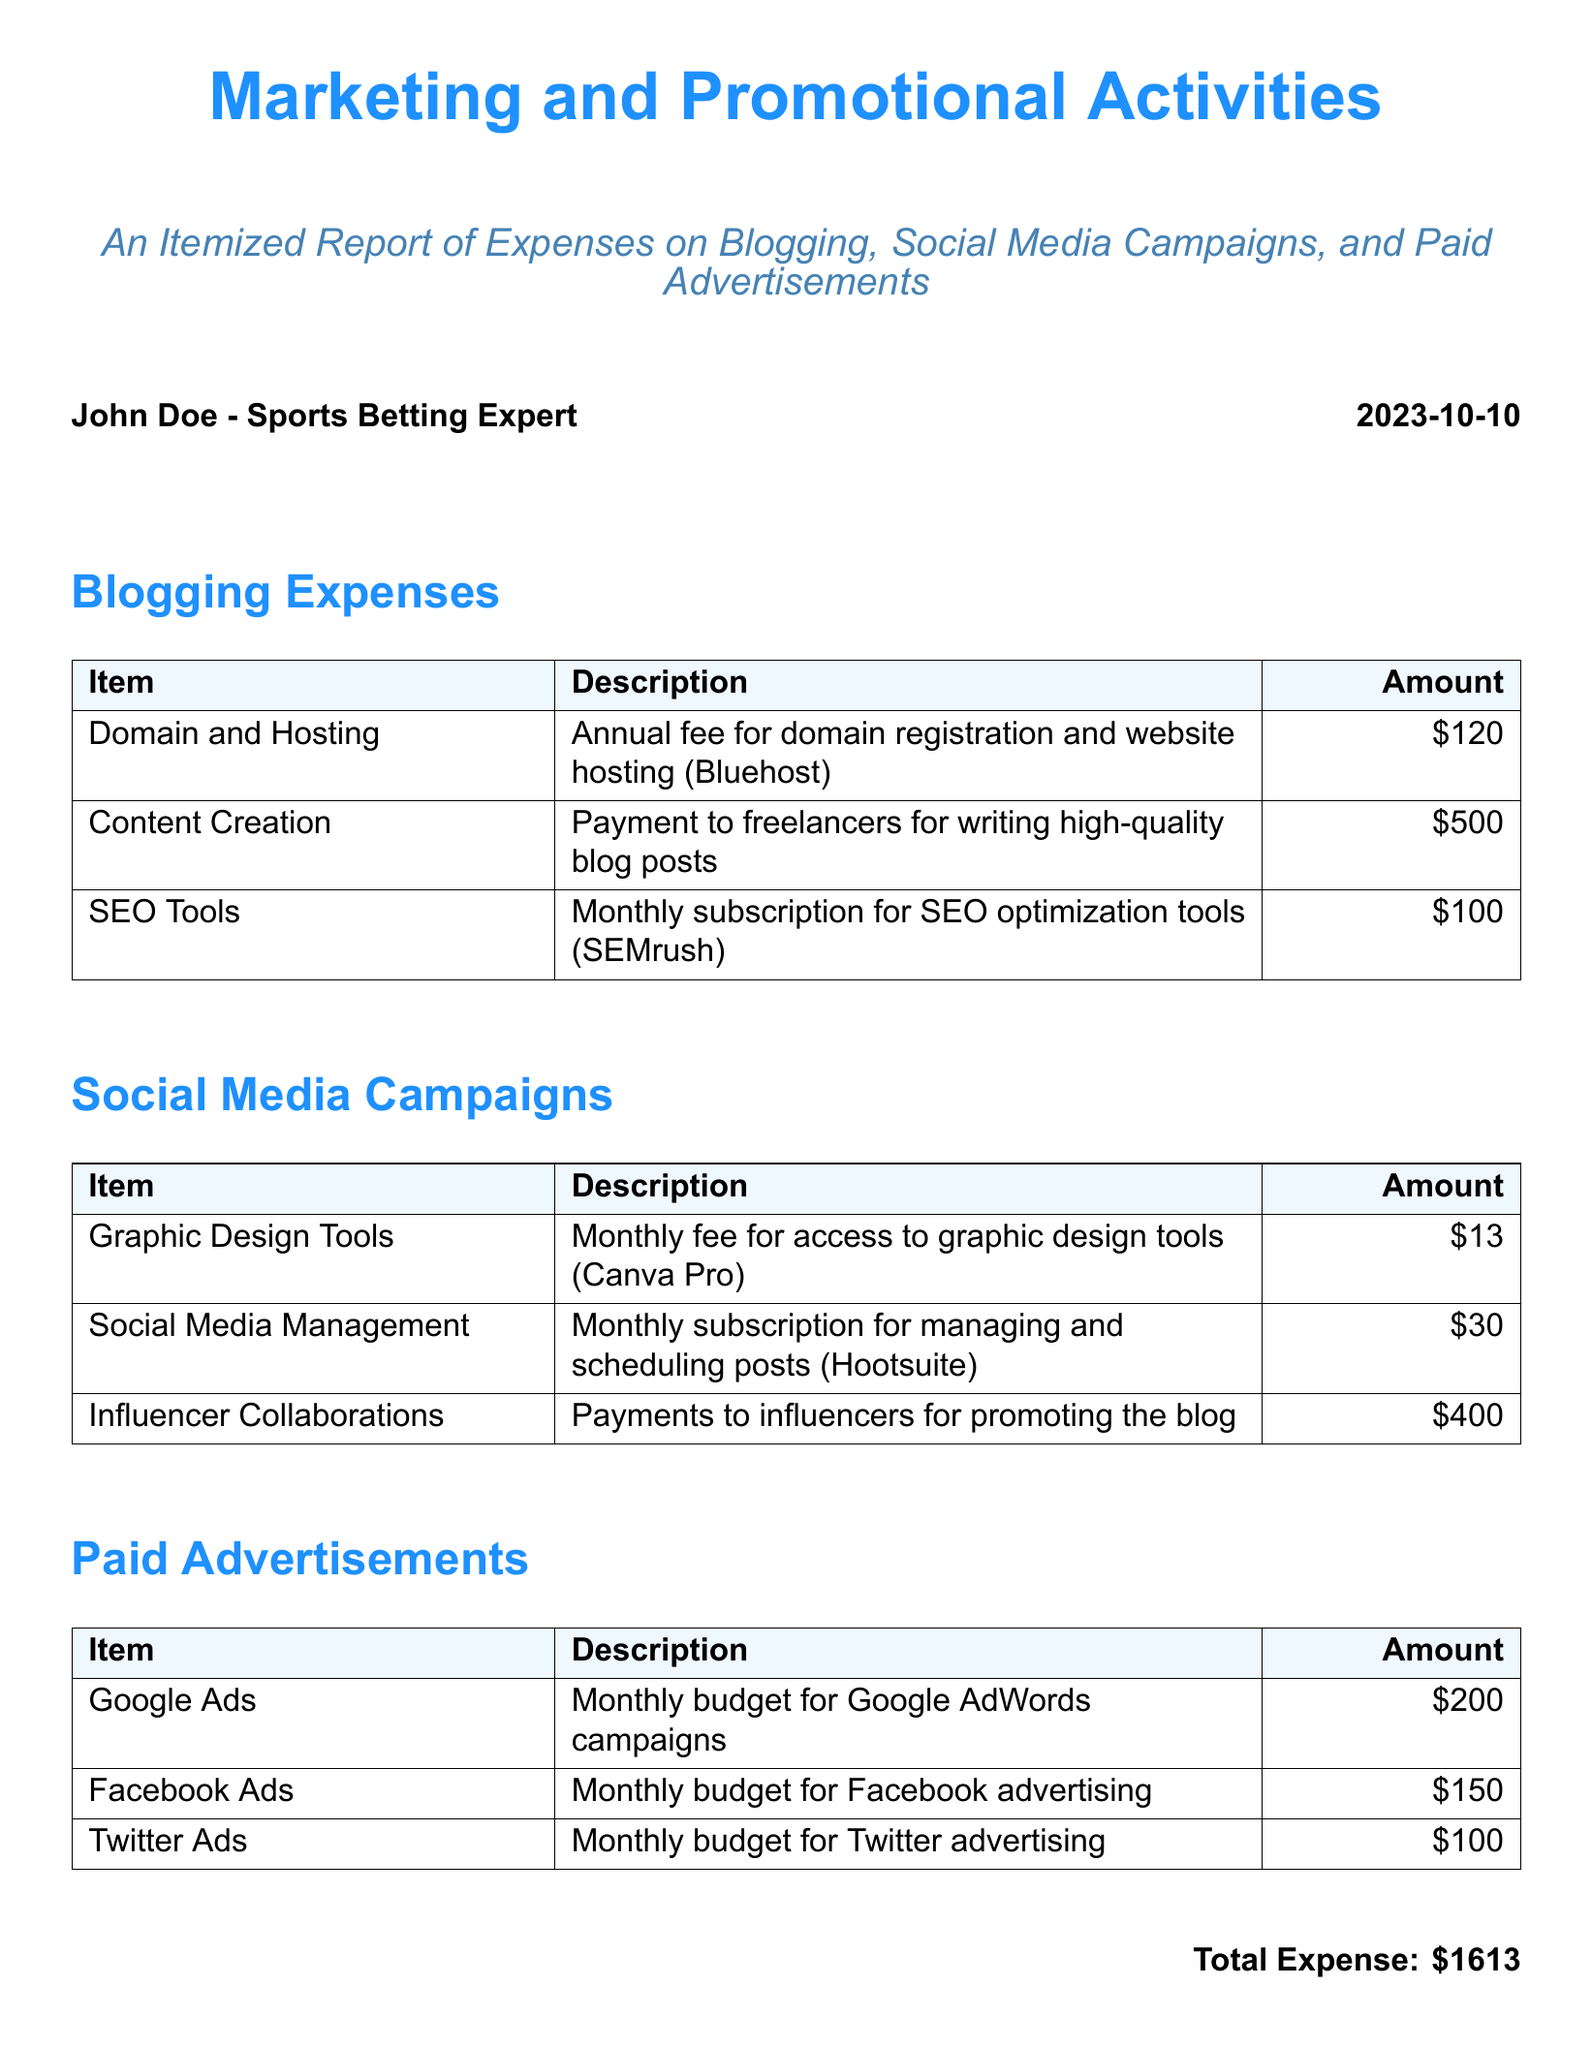What is the total expense? The total expense is summarized at the end of the document, which is the sum of all itemized expenses.
Answer: $1613 What is the expense for Content Creation? The specific expense for Content Creation is listed under Blogging Expenses in the document.
Answer: $500 How much was spent on Influencer Collaborations? The expense for Influencer Collaborations is found under the Social Media Campaigns section.
Answer: $400 What is the monthly fee for graphic design tools? This information is provided in the Social Media Campaigns section listing Graphic Design Tools.
Answer: $13 What service is associated with a $100 expense monthly? The $100 expense is associated with SEO optimization tools in the Blogging Expenses section.
Answer: SEO Tools Which advertising platform has the lowest monthly budget? The question requires comparing the monthly budgets listed for each advertising platform.
Answer: Twitter Ads Who is the author of the expense report? The document states the author's name at the top of the report.
Answer: John Doe What platform is used for social media management? The document specifies the platform used for social media management in the Social Media Campaigns section.
Answer: Hootsuite What is the monthly budget for Google Ads? This information is detailed in the Paid Advertisements section of the document.
Answer: $200 